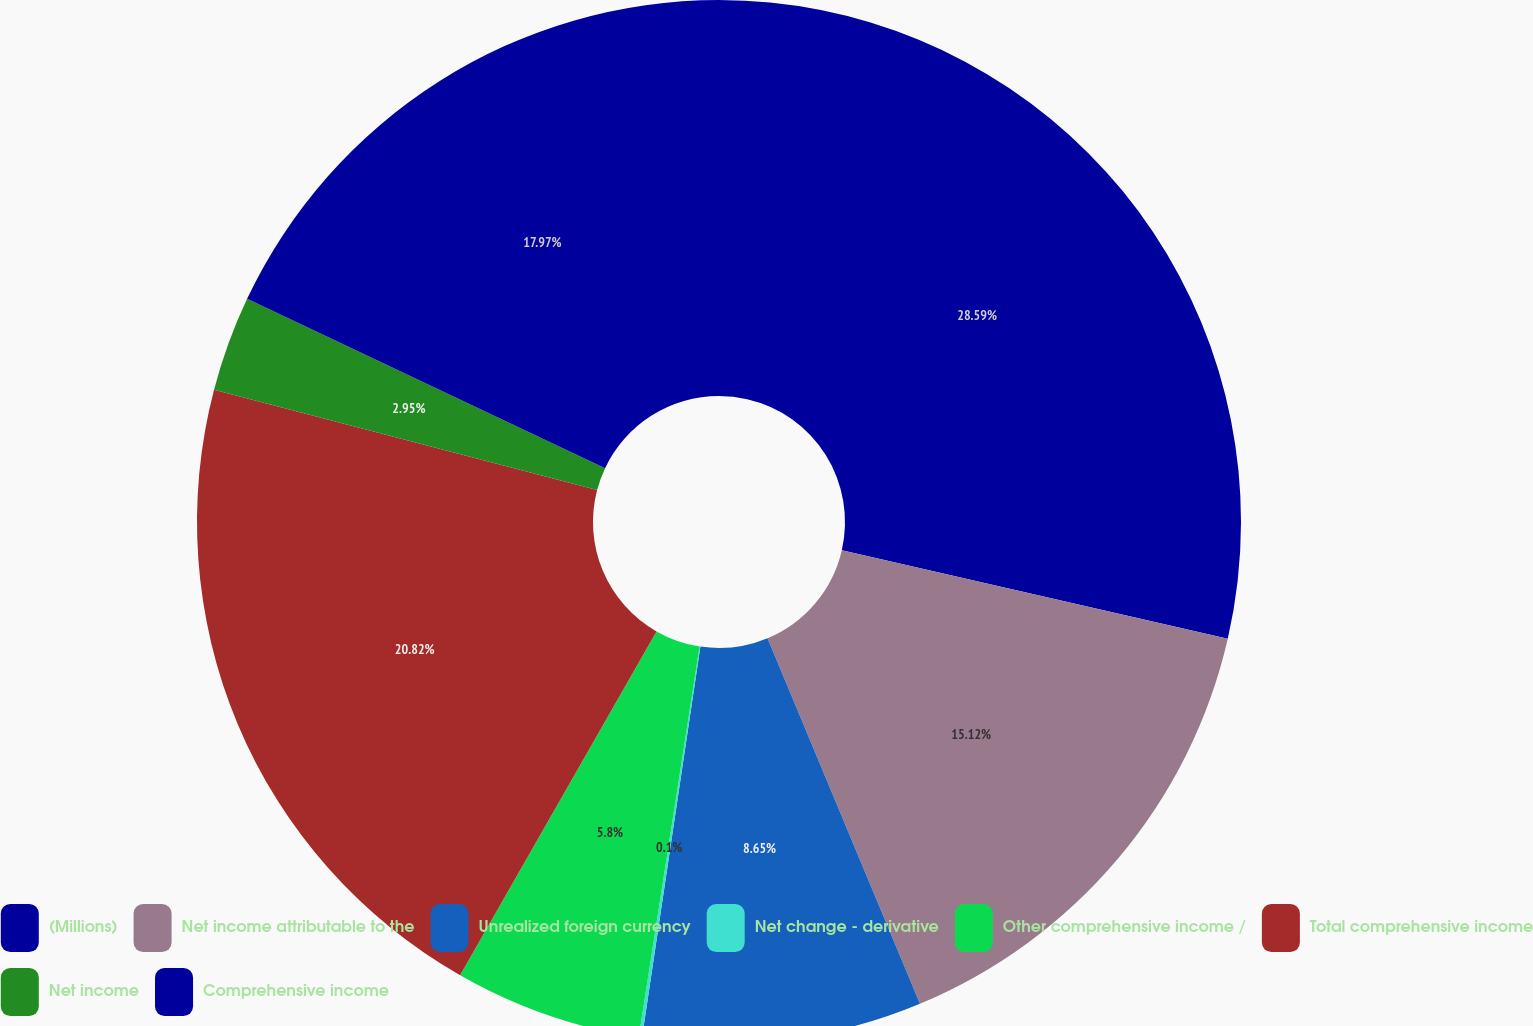<chart> <loc_0><loc_0><loc_500><loc_500><pie_chart><fcel>(Millions)<fcel>Net income attributable to the<fcel>Unrealized foreign currency<fcel>Net change - derivative<fcel>Other comprehensive income /<fcel>Total comprehensive income<fcel>Net income<fcel>Comprehensive income<nl><fcel>28.59%<fcel>15.12%<fcel>8.65%<fcel>0.1%<fcel>5.8%<fcel>20.82%<fcel>2.95%<fcel>17.97%<nl></chart> 